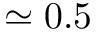Convert formula to latex. <formula><loc_0><loc_0><loc_500><loc_500>\simeq 0 . 5</formula> 